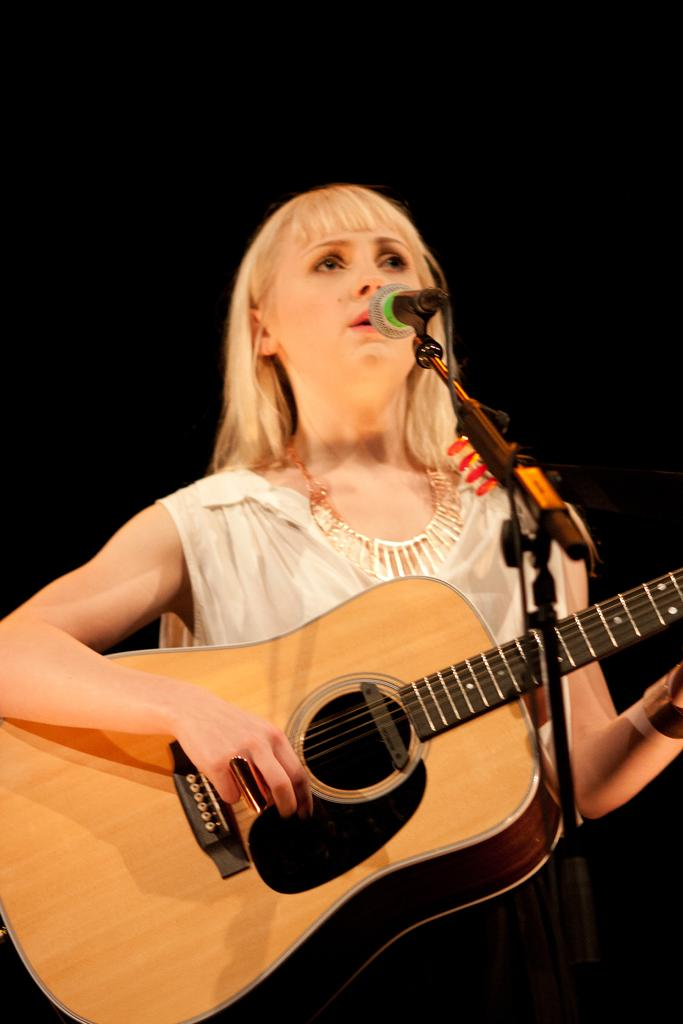Who is the main subject in the image? There is a woman in the image. What is the woman doing in the image? The woman is playing a guitar and singing on a mic. What type of shock can be seen affecting the woman's skin in the image? There is no shock or any indication of a shock affecting the woman's skin in the image. 